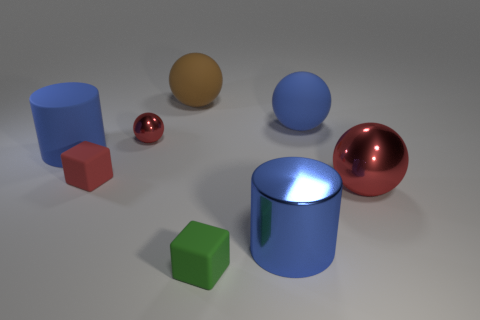There is a small cube in front of the red metallic object to the right of the blue metallic cylinder; what is its color?
Give a very brief answer. Green. How many large rubber things are the same color as the small sphere?
Give a very brief answer. 0. Does the big metal cylinder have the same color as the matte object that is on the right side of the blue metallic thing?
Your answer should be very brief. Yes. Are there fewer blue rubber things than small green blocks?
Offer a terse response. No. Is the number of green objects behind the small green cube greater than the number of small matte cubes that are to the left of the tiny red metallic ball?
Offer a terse response. No. Is the material of the tiny red block the same as the large brown ball?
Make the answer very short. Yes. How many big cylinders are in front of the rubber object on the left side of the small red rubber cube?
Provide a short and direct response. 1. Do the matte sphere to the left of the big blue ball and the metal cylinder have the same color?
Your answer should be compact. No. What number of objects are large red things or large matte objects behind the large blue matte cylinder?
Make the answer very short. 3. Do the large blue object that is on the left side of the tiny green object and the blue metallic thing right of the large brown rubber ball have the same shape?
Your response must be concise. Yes. 